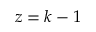Convert formula to latex. <formula><loc_0><loc_0><loc_500><loc_500>z = k - 1</formula> 